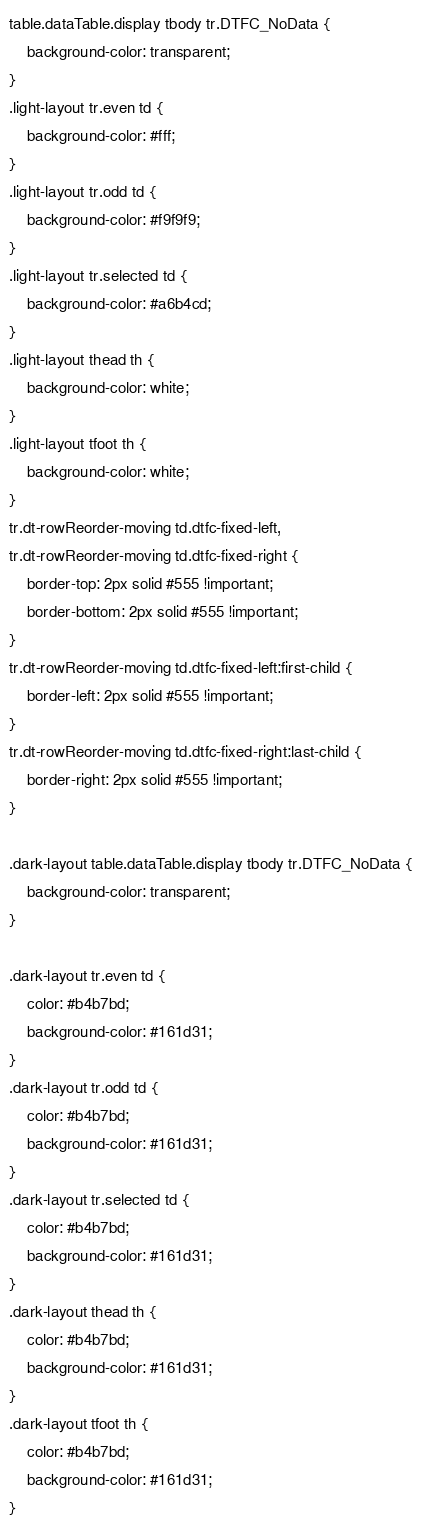Convert code to text. <code><loc_0><loc_0><loc_500><loc_500><_CSS_>table.dataTable.display tbody tr.DTFC_NoData {
	background-color: transparent;
}
.light-layout tr.even td {
	background-color: #fff;
}
.light-layout tr.odd td {
	background-color: #f9f9f9;
}
.light-layout tr.selected td {
	background-color: #a6b4cd;
}
.light-layout thead th {
	background-color: white;
}
.light-layout tfoot th {
	background-color: white;
}
tr.dt-rowReorder-moving td.dtfc-fixed-left,
tr.dt-rowReorder-moving td.dtfc-fixed-right {
	border-top: 2px solid #555 !important;
	border-bottom: 2px solid #555 !important;
}
tr.dt-rowReorder-moving td.dtfc-fixed-left:first-child {
	border-left: 2px solid #555 !important;
}
tr.dt-rowReorder-moving td.dtfc-fixed-right:last-child {
	border-right: 2px solid #555 !important;
}

.dark-layout table.dataTable.display tbody tr.DTFC_NoData {
	background-color: transparent;
}

.dark-layout tr.even td {
	color: #b4b7bd;
	background-color: #161d31;
}
.dark-layout tr.odd td {
	color: #b4b7bd;
	background-color: #161d31;
}
.dark-layout tr.selected td {
	color: #b4b7bd;
	background-color: #161d31;
}
.dark-layout thead th {
	color: #b4b7bd;
	background-color: #161d31;
}
.dark-layout tfoot th {
	color: #b4b7bd;
	background-color: #161d31;
}
</code> 